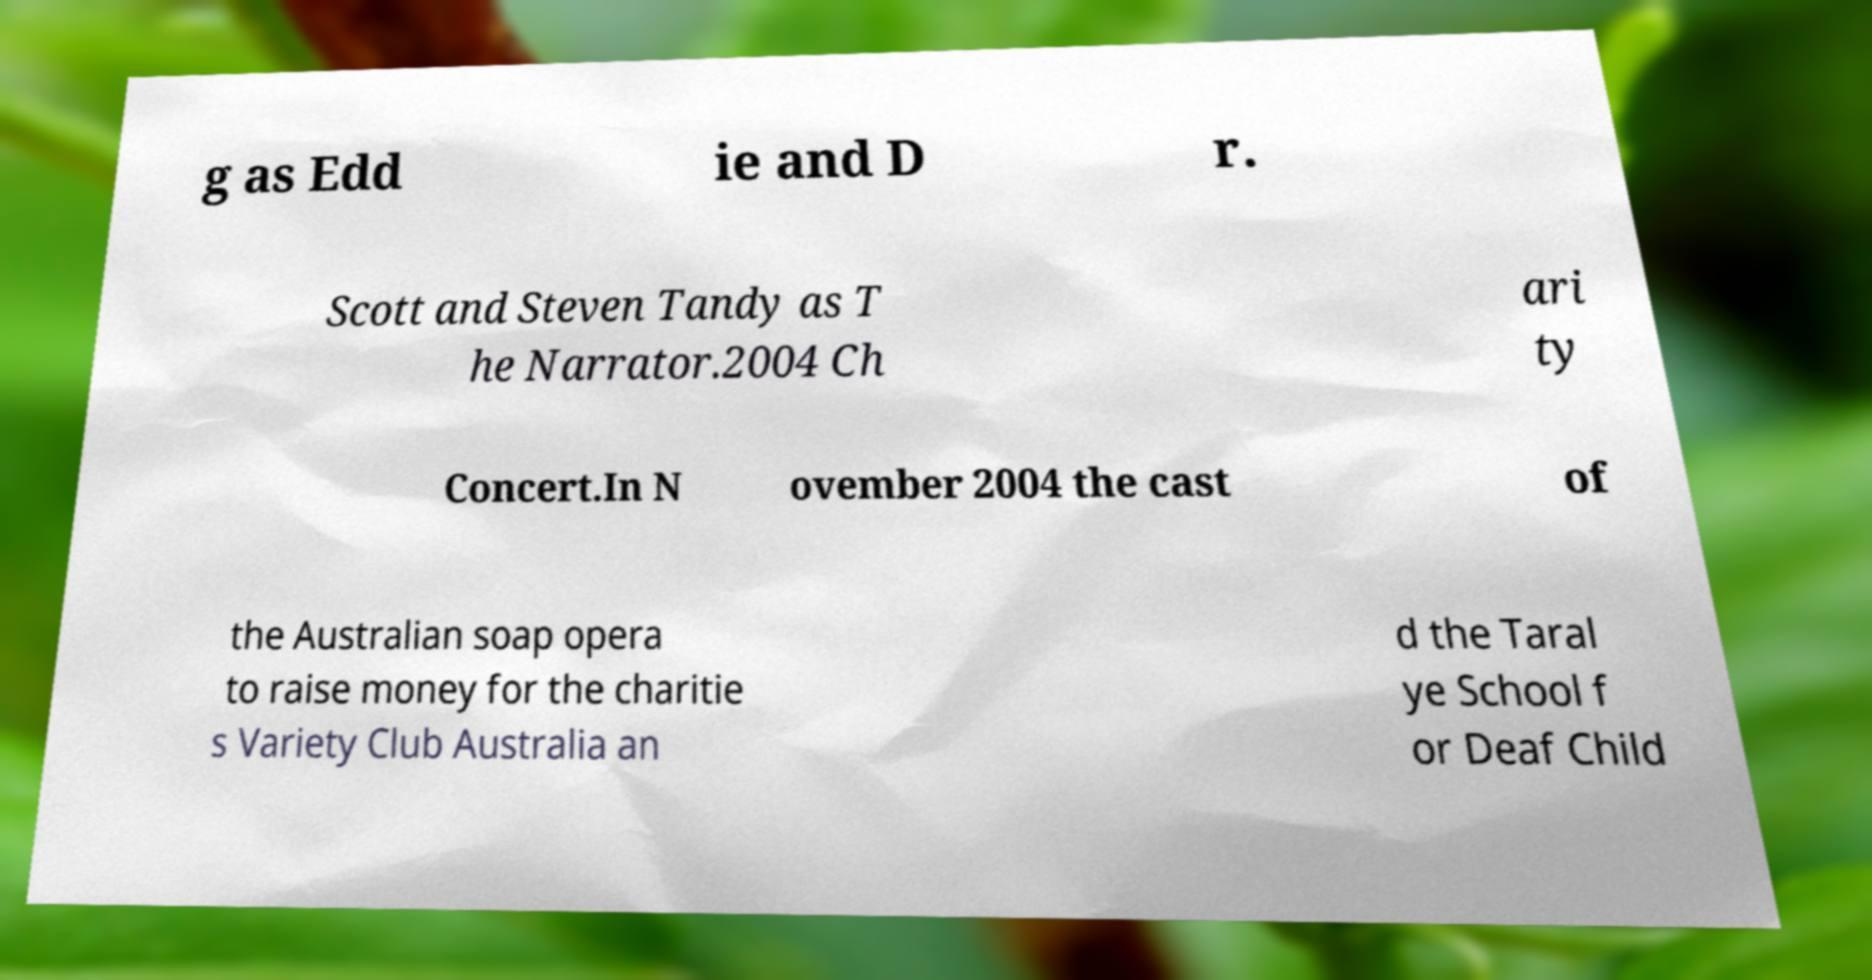Can you accurately transcribe the text from the provided image for me? g as Edd ie and D r. Scott and Steven Tandy as T he Narrator.2004 Ch ari ty Concert.In N ovember 2004 the cast of the Australian soap opera to raise money for the charitie s Variety Club Australia an d the Taral ye School f or Deaf Child 